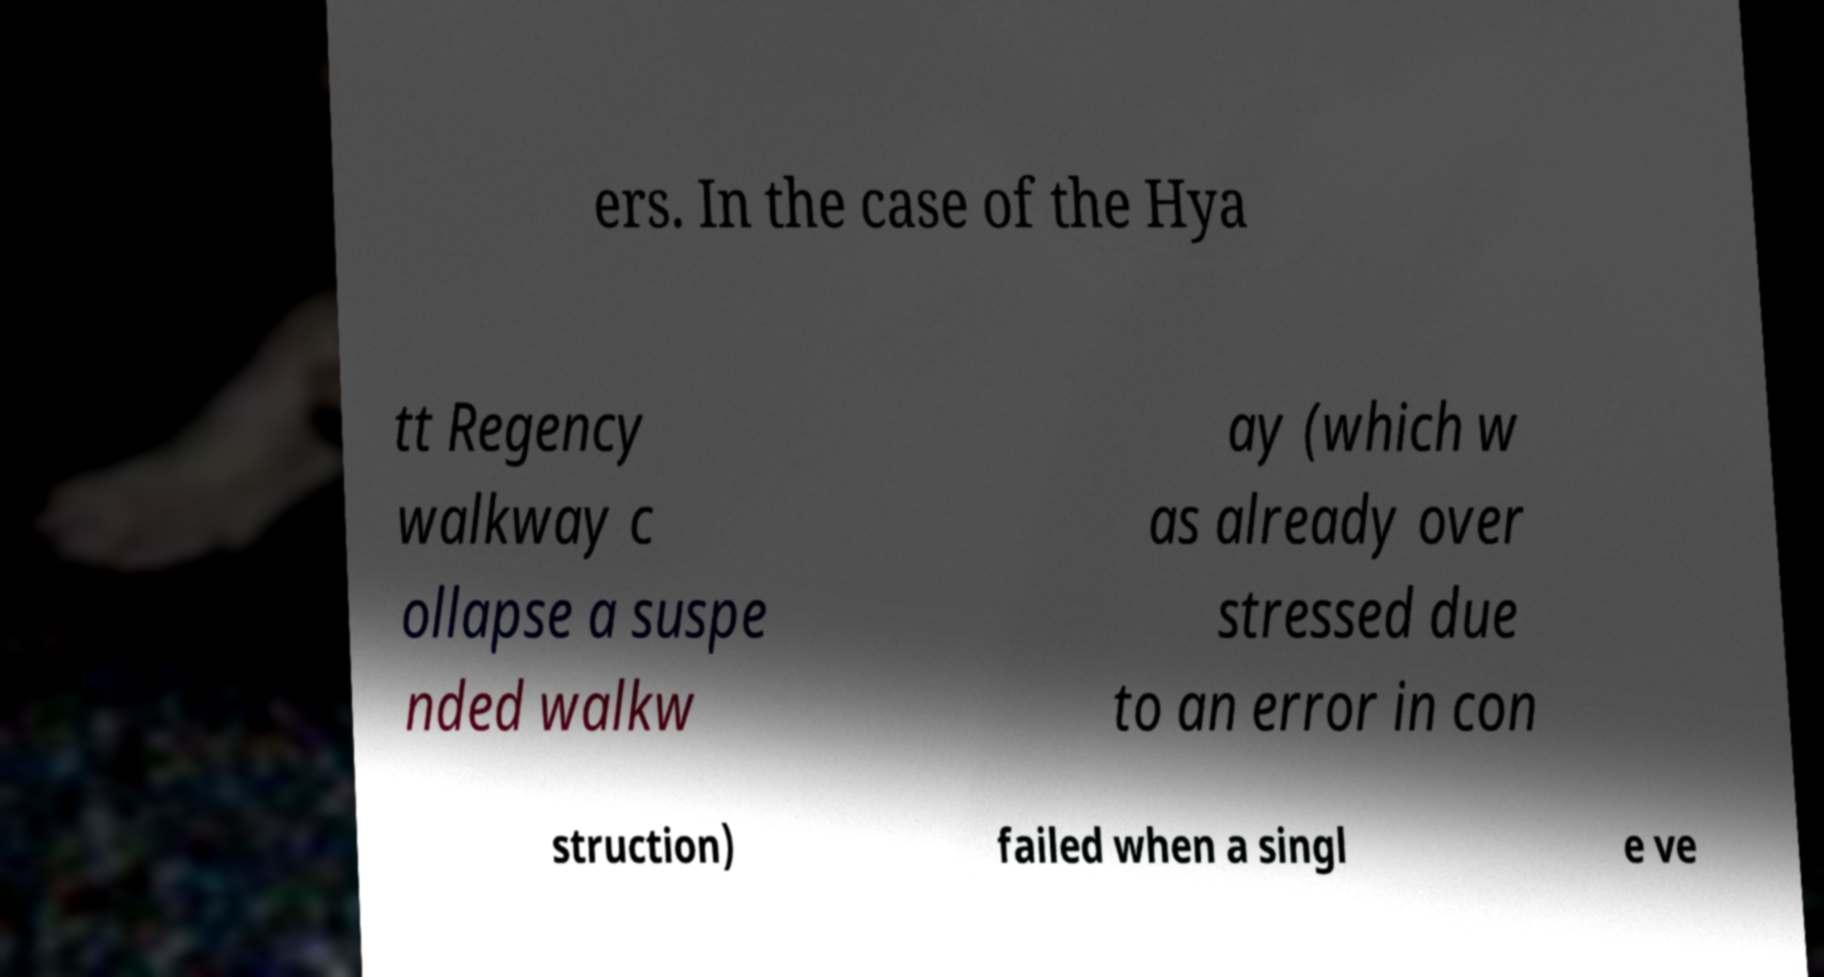Please read and relay the text visible in this image. What does it say? ers. In the case of the Hya tt Regency walkway c ollapse a suspe nded walkw ay (which w as already over stressed due to an error in con struction) failed when a singl e ve 